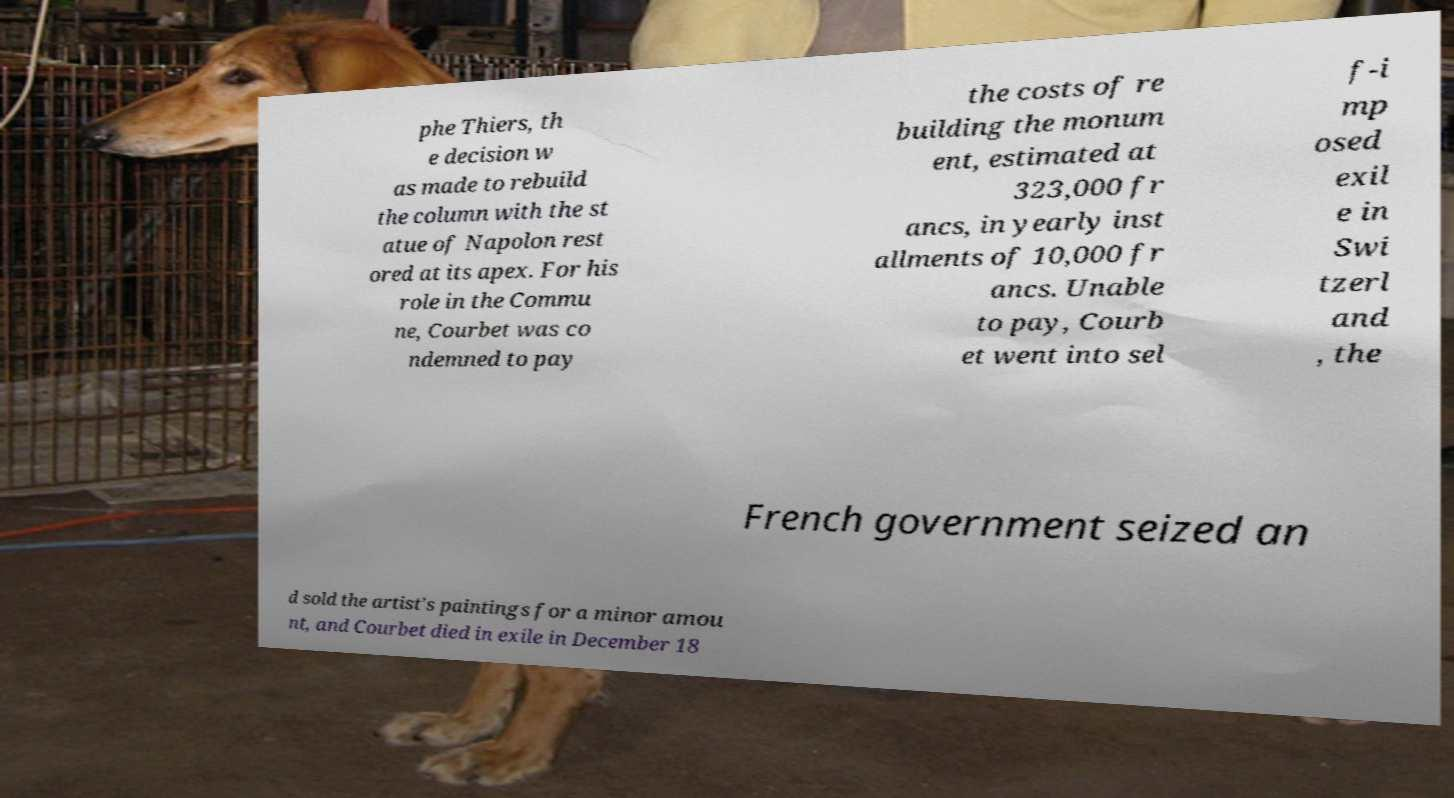For documentation purposes, I need the text within this image transcribed. Could you provide that? phe Thiers, th e decision w as made to rebuild the column with the st atue of Napolon rest ored at its apex. For his role in the Commu ne, Courbet was co ndemned to pay the costs of re building the monum ent, estimated at 323,000 fr ancs, in yearly inst allments of 10,000 fr ancs. Unable to pay, Courb et went into sel f-i mp osed exil e in Swi tzerl and , the French government seized an d sold the artist's paintings for a minor amou nt, and Courbet died in exile in December 18 